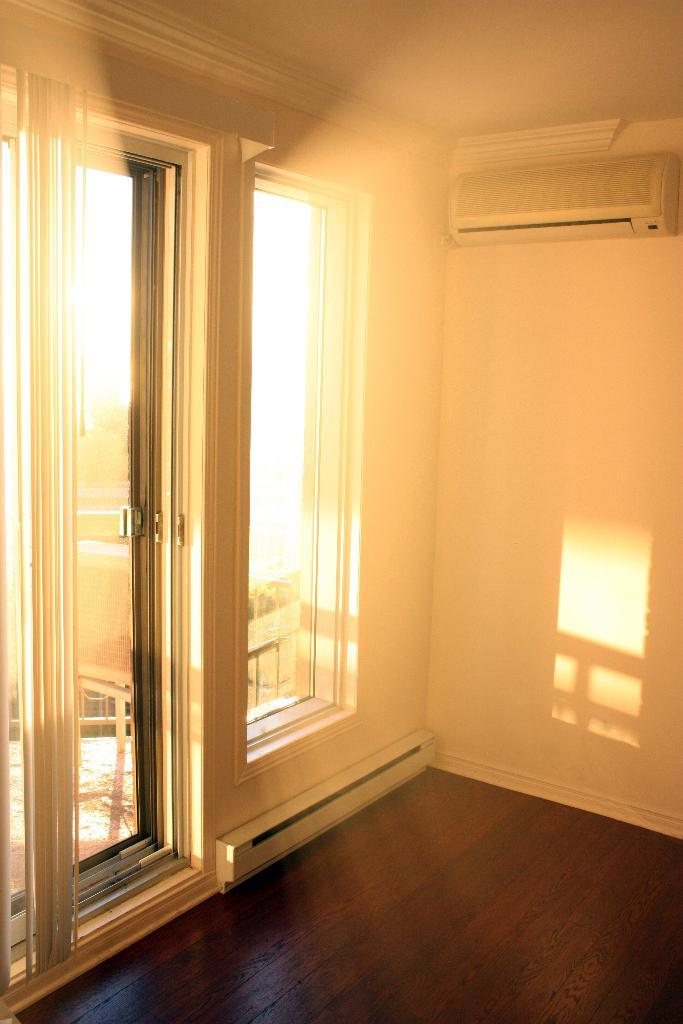What type of space is shown in the image? The image is an inside view of a room. What can be seen on one of the walls in the room? There is a wall with an AC in the room. How can natural light enter the room? There is a window in the room. Is there a way to enter or exit the room? Yes, there is a door in the room. How many people are gathered around the grandmother in the image? There is no grandmother or crowd present in the image. 